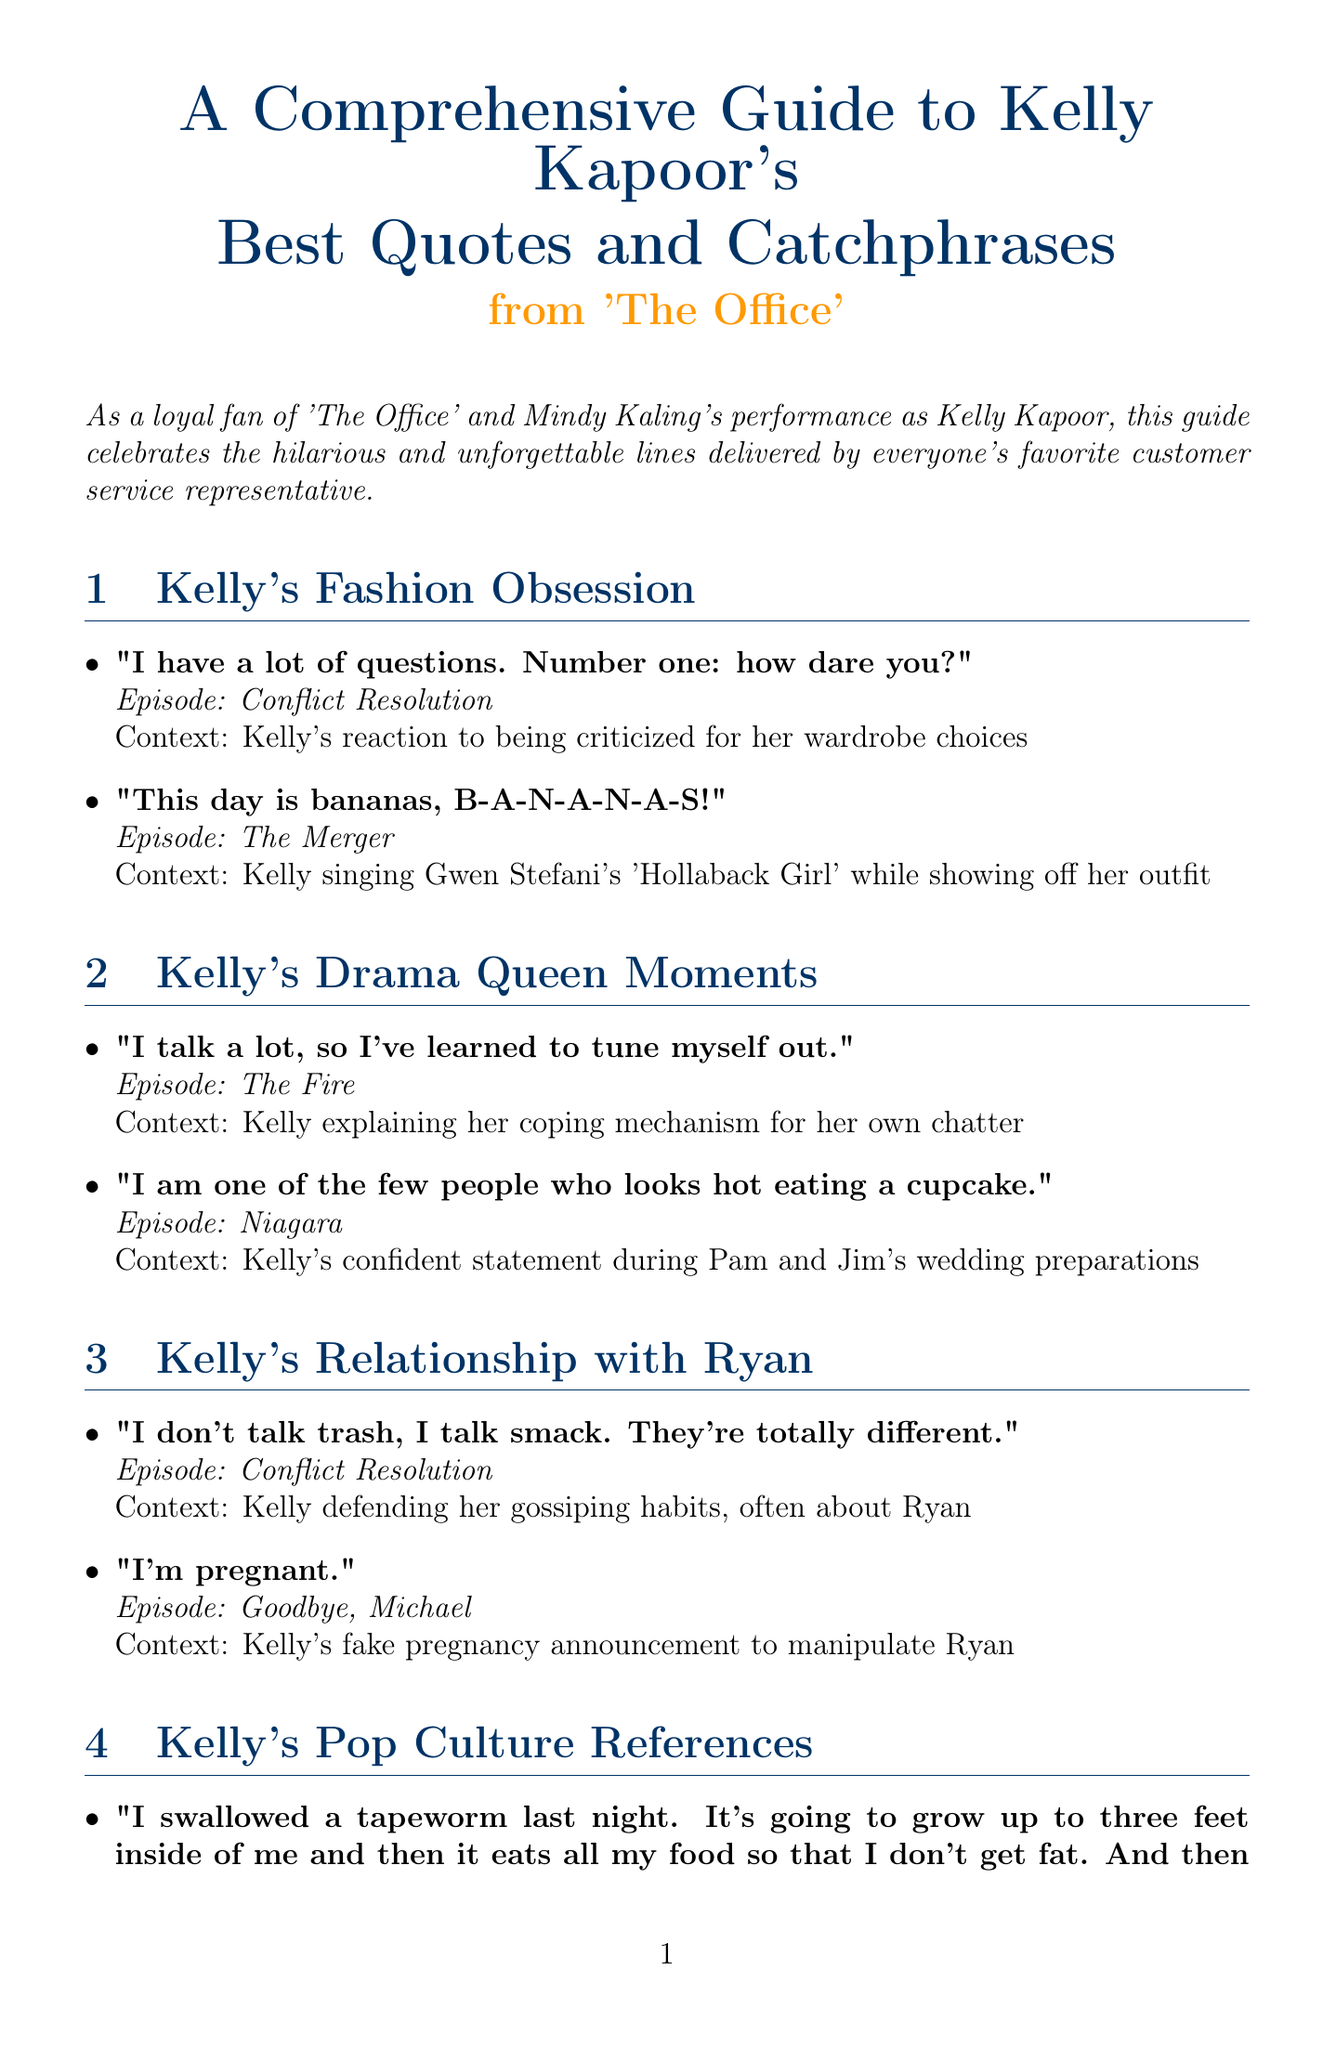What is the title of the guide? The title is explicitly stated at the beginning of the document as "A Comprehensive Guide to Kelly Kapoor's Best Quotes and Catchphrases from 'The Office'."
Answer: A Comprehensive Guide to Kelly Kapoor's Best Quotes and Catchphrases from 'The Office' Who portrayed Kelly Kapoor? The introduction notes that Mindy Kaling's performance is celebrated in the guide, indicating she portrayed Kelly Kapoor.
Answer: Mindy Kaling In which episode does Kelly say, "I have a lot of questions. Number one: how dare you?" Each quote is followed by the episode name; this quote is from "Conflict Resolution."
Answer: Conflict Resolution What phrase does Kelly use to emphasize her outfit excitement in "The Merger"? The document mentions the specific quote, "This day is bananas, B-A-N-A-N-A-S!" indicating her excitement about her outfit in that episode.
Answer: This day is bananas, B-A-N-A-N-A-S! What is one of Kelly's coping mechanisms she mentions in "The Fire"? Kelly states, "I talk a lot, so I've learned to tune myself out," which gives insight into her coping mechanism.
Answer: I talk a lot, so I've learned to tune myself out What concept does Kelly reference in "Weight Loss"? In this episode, Kelly mentions a tapeworm and a questionable weight loss method.
Answer: A tapeworm What does Kelly joke about in "Money"? There is a notable quote where she references getting hit by a bus in relation to her job, making a joke about insurance fraud.
Answer: Getting hit by a bus Which section includes Kelly's quotes about her relationship with Ryan? The guide organizes quotes into sections, and this specific theme is found in "Kelly's Relationship with Ryan."
Answer: Kelly's Relationship with Ryan Name one additional resource mentioned in the document. The document lists several additional resources, one of which is "The Office Ladies Podcast."
Answer: The Office Ladies Podcast 